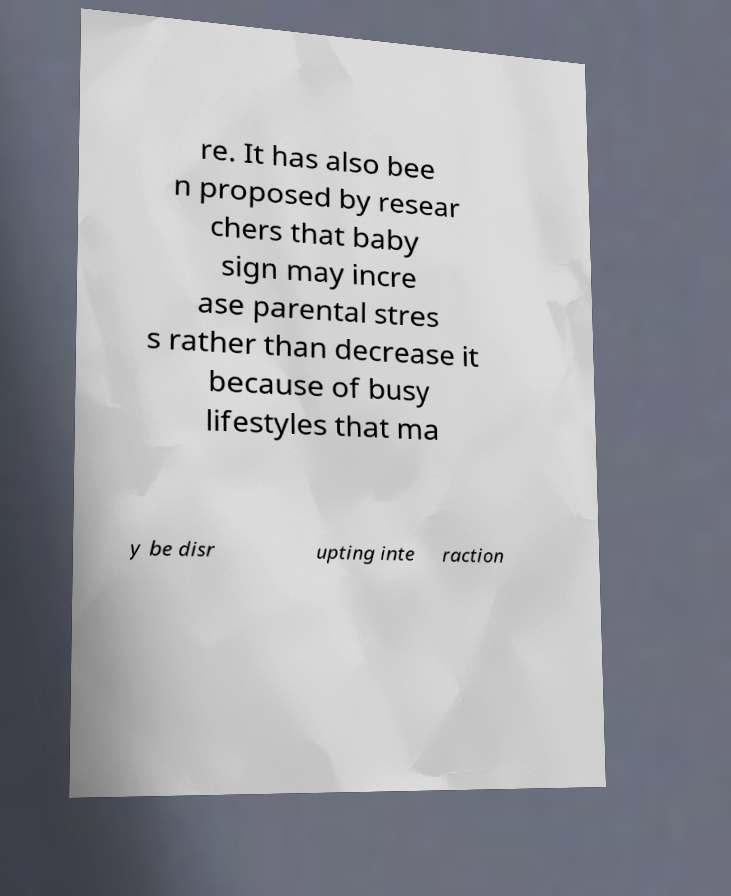Could you extract and type out the text from this image? re. It has also bee n proposed by resear chers that baby sign may incre ase parental stres s rather than decrease it because of busy lifestyles that ma y be disr upting inte raction 